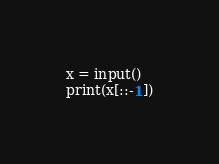<code> <loc_0><loc_0><loc_500><loc_500><_Python_>x = input()
print(x[::-1])
</code> 